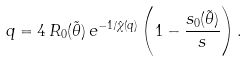<formula> <loc_0><loc_0><loc_500><loc_500>q = 4 \, R _ { 0 } ( \tilde { \theta } ) \, e ^ { - 1 / \hat { \chi } ( q ) } \left ( 1 - \frac { s _ { 0 } ( \tilde { \theta } ) } { s } \right ) .</formula> 